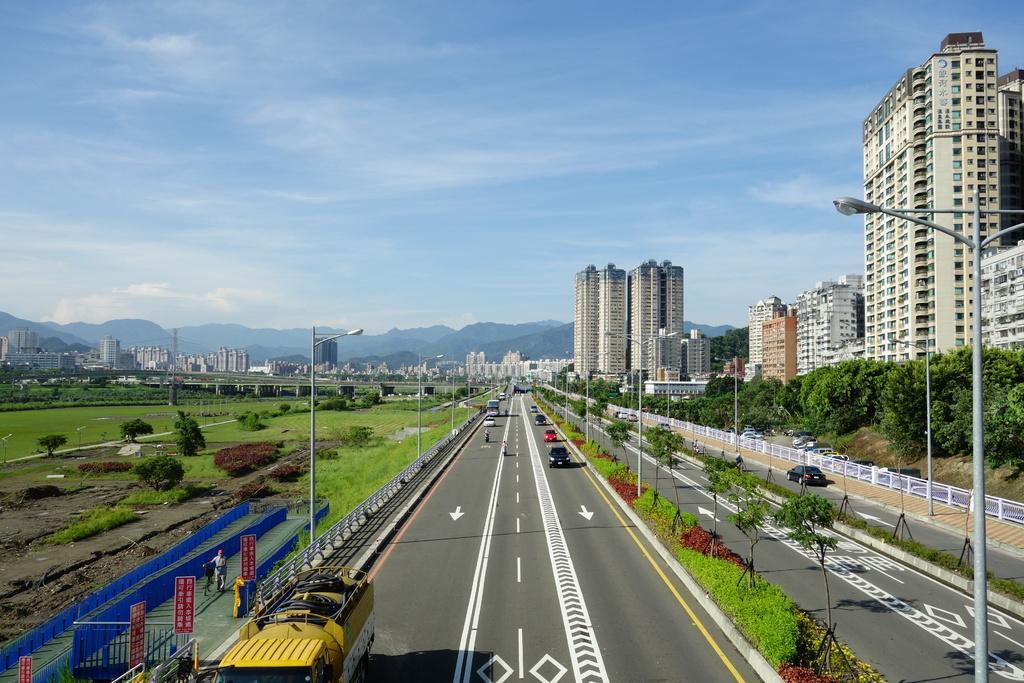In one or two sentences, can you explain what this image depicts? In this image we can see vehicles on the road, after that we can see trees and plants, we can see street lights, we can see buildings, on the right we can see grass and one person, in the background we can see hills, at the top we can see the sky with clouds. 